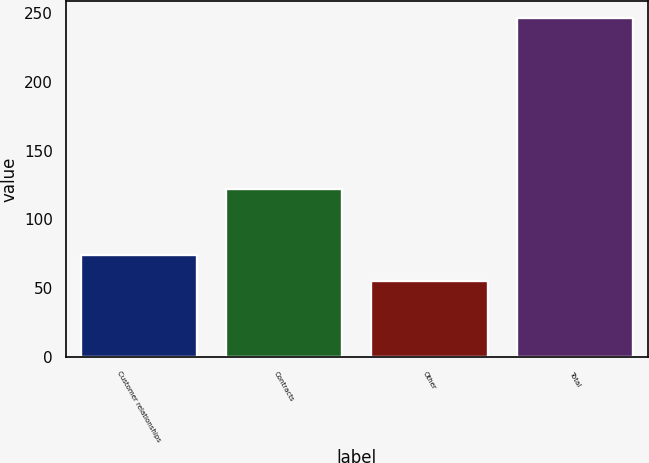Convert chart. <chart><loc_0><loc_0><loc_500><loc_500><bar_chart><fcel>Customer relationships<fcel>Contracts<fcel>Other<fcel>Total<nl><fcel>74.1<fcel>122<fcel>55<fcel>246<nl></chart> 